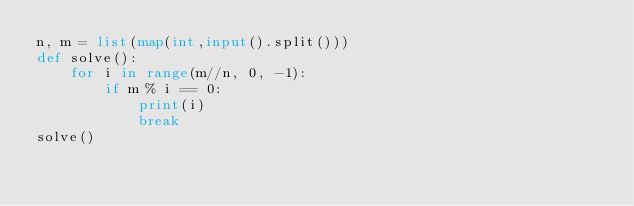<code> <loc_0><loc_0><loc_500><loc_500><_Python_>n, m = list(map(int,input().split()))
def solve():
    for i in range(m//n, 0, -1):
        if m % i == 0:
            print(i)
            break
solve()</code> 